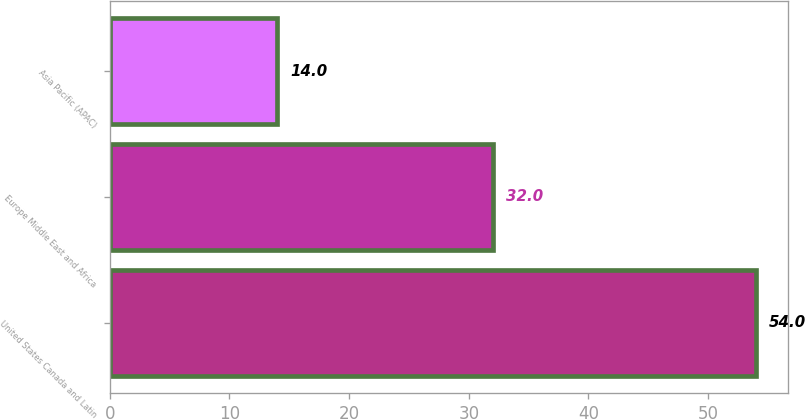<chart> <loc_0><loc_0><loc_500><loc_500><bar_chart><fcel>United States Canada and Latin<fcel>Europe Middle East and Africa<fcel>Asia Pacific (APAC)<nl><fcel>54<fcel>32<fcel>14<nl></chart> 